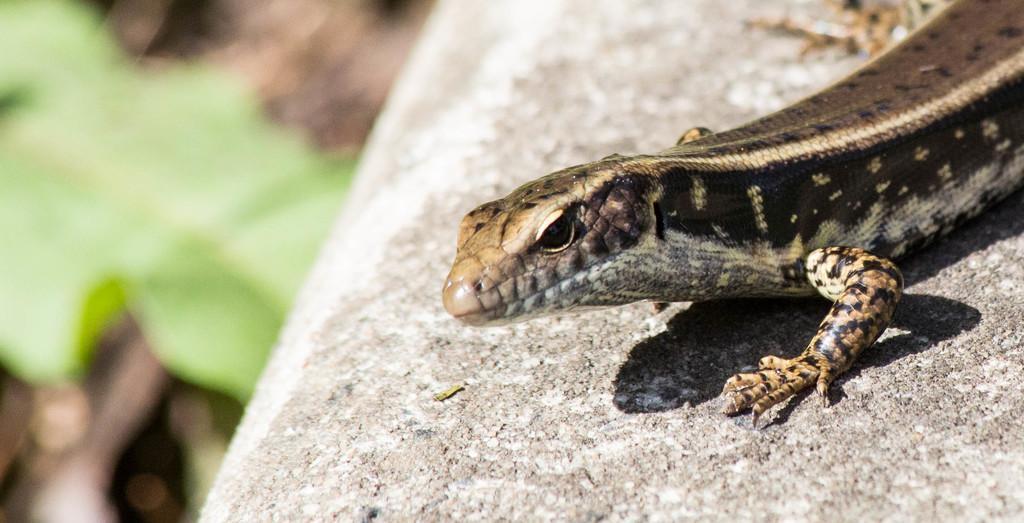Could you give a brief overview of what you see in this image? In this picture we can see reptile on the surface. In the background of the image it is blurry. 